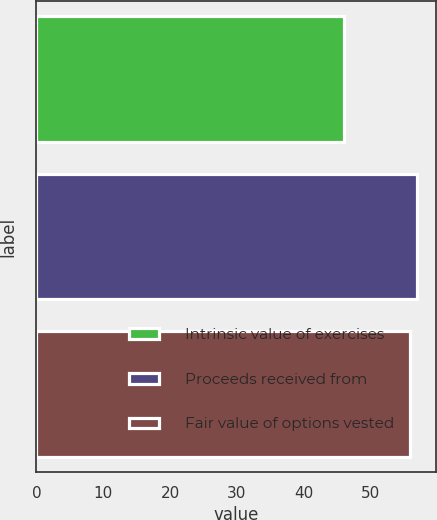Convert chart to OTSL. <chart><loc_0><loc_0><loc_500><loc_500><bar_chart><fcel>Intrinsic value of exercises<fcel>Proceeds received from<fcel>Fair value of options vested<nl><fcel>46.1<fcel>56.94<fcel>55.9<nl></chart> 